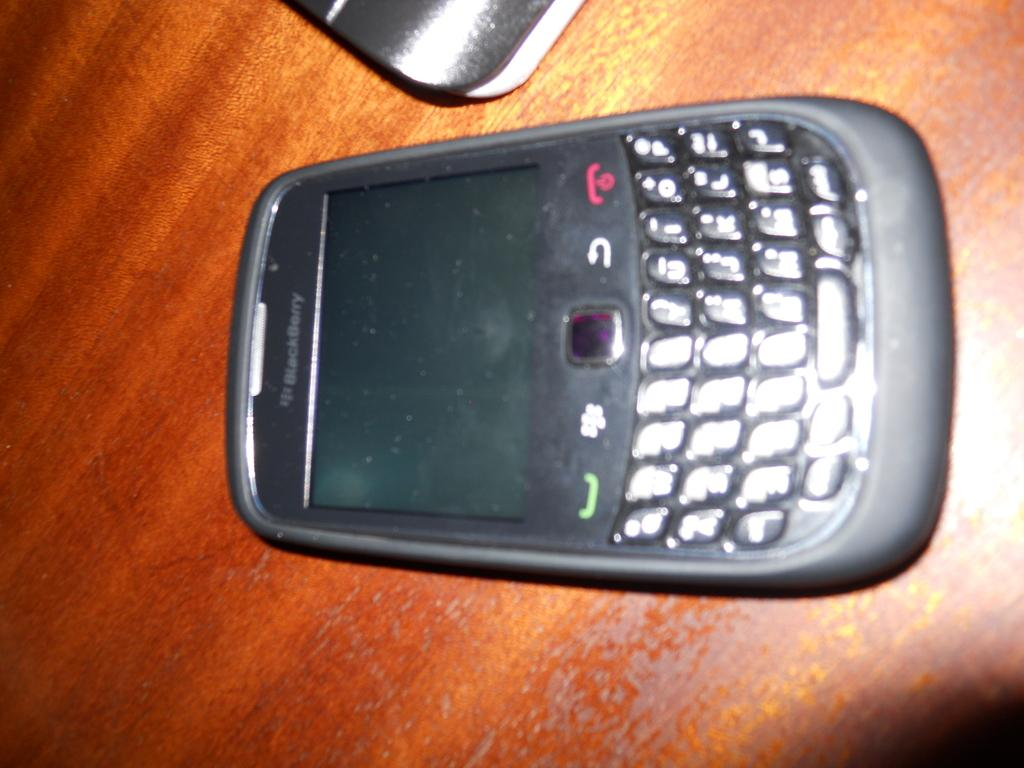Provide a one-sentence caption for the provided image. A Blackberry phone with a keyboard sits on a table. 